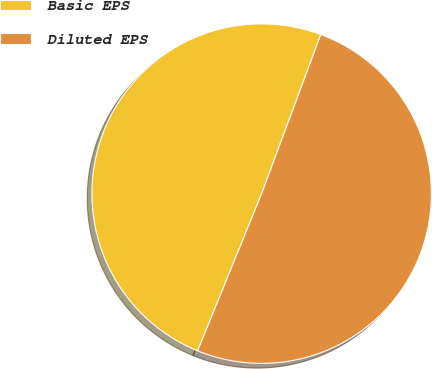Convert chart to OTSL. <chart><loc_0><loc_0><loc_500><loc_500><pie_chart><fcel>Basic EPS<fcel>Diluted EPS<nl><fcel>49.51%<fcel>50.49%<nl></chart> 